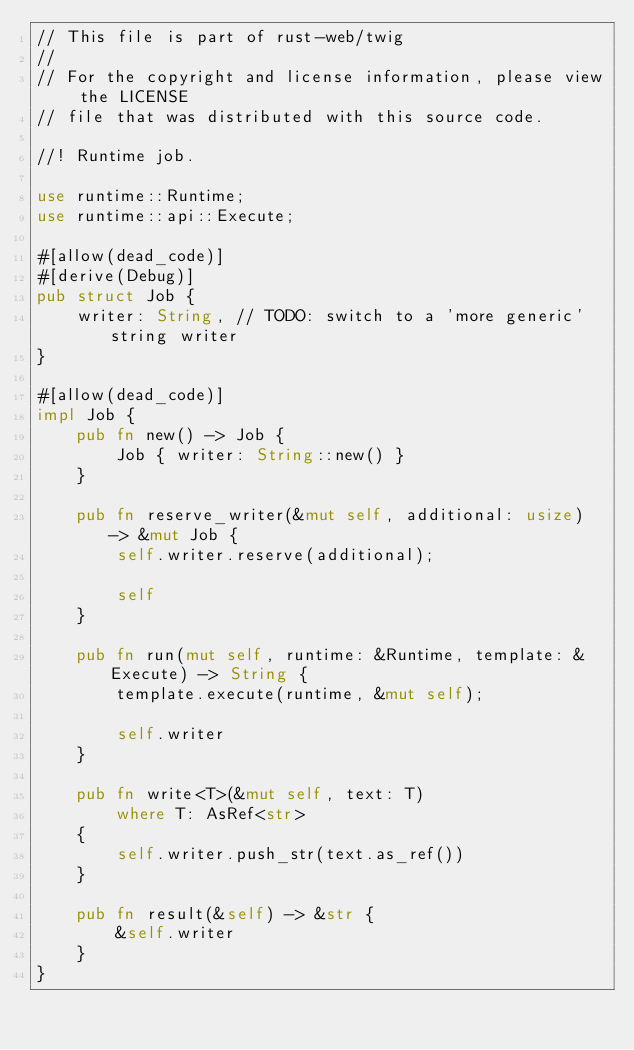<code> <loc_0><loc_0><loc_500><loc_500><_Rust_>// This file is part of rust-web/twig
//
// For the copyright and license information, please view the LICENSE
// file that was distributed with this source code.

//! Runtime job.

use runtime::Runtime;
use runtime::api::Execute;

#[allow(dead_code)]
#[derive(Debug)]
pub struct Job {
    writer: String, // TODO: switch to a 'more generic' string writer
}

#[allow(dead_code)]
impl Job {
    pub fn new() -> Job {
        Job { writer: String::new() }
    }

    pub fn reserve_writer(&mut self, additional: usize) -> &mut Job {
        self.writer.reserve(additional);

        self
    }

    pub fn run(mut self, runtime: &Runtime, template: &Execute) -> String {
        template.execute(runtime, &mut self);

        self.writer
    }

    pub fn write<T>(&mut self, text: T)
        where T: AsRef<str>
    {
        self.writer.push_str(text.as_ref())
    }

    pub fn result(&self) -> &str {
        &self.writer
    }
}
</code> 